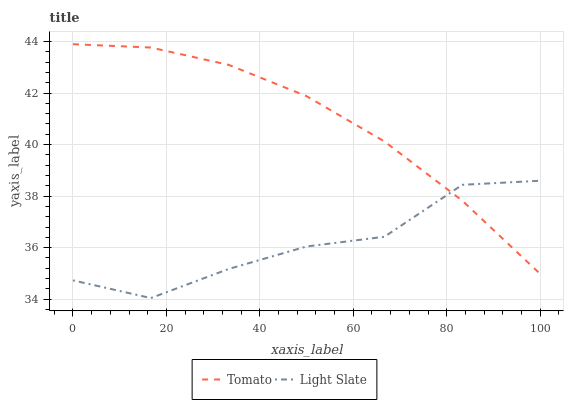Does Light Slate have the minimum area under the curve?
Answer yes or no. Yes. Does Tomato have the maximum area under the curve?
Answer yes or no. Yes. Does Light Slate have the maximum area under the curve?
Answer yes or no. No. Is Tomato the smoothest?
Answer yes or no. Yes. Is Light Slate the roughest?
Answer yes or no. Yes. Is Light Slate the smoothest?
Answer yes or no. No. Does Light Slate have the lowest value?
Answer yes or no. Yes. Does Tomato have the highest value?
Answer yes or no. Yes. Does Light Slate have the highest value?
Answer yes or no. No. Does Light Slate intersect Tomato?
Answer yes or no. Yes. Is Light Slate less than Tomato?
Answer yes or no. No. Is Light Slate greater than Tomato?
Answer yes or no. No. 